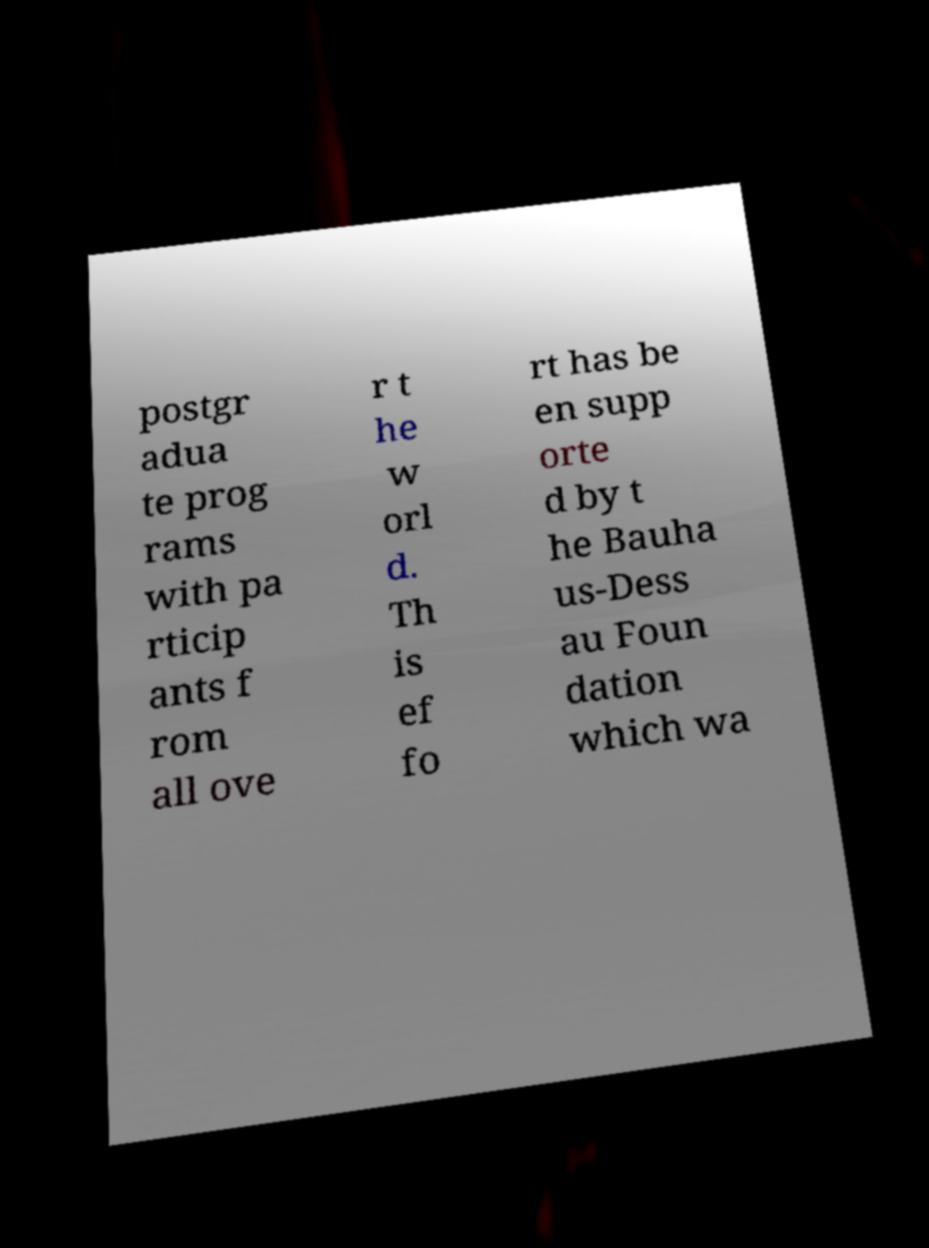Can you accurately transcribe the text from the provided image for me? postgr adua te prog rams with pa rticip ants f rom all ove r t he w orl d. Th is ef fo rt has be en supp orte d by t he Bauha us-Dess au Foun dation which wa 